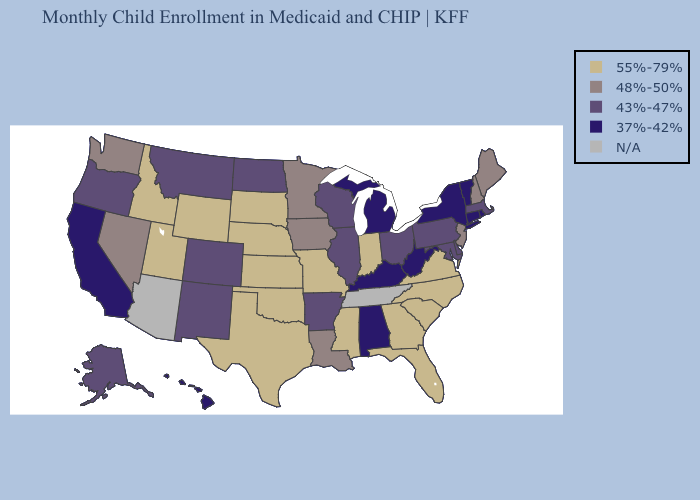Among the states that border Kentucky , does West Virginia have the lowest value?
Answer briefly. Yes. What is the lowest value in states that border Tennessee?
Answer briefly. 37%-42%. What is the value of South Dakota?
Keep it brief. 55%-79%. Among the states that border Colorado , does New Mexico have the lowest value?
Short answer required. Yes. Does the first symbol in the legend represent the smallest category?
Give a very brief answer. No. What is the value of New Mexico?
Keep it brief. 43%-47%. Name the states that have a value in the range 43%-47%?
Be succinct. Alaska, Arkansas, Colorado, Delaware, Illinois, Maryland, Massachusetts, Montana, New Mexico, North Dakota, Ohio, Oregon, Pennsylvania, Wisconsin. What is the value of Nevada?
Short answer required. 48%-50%. What is the value of Massachusetts?
Write a very short answer. 43%-47%. How many symbols are there in the legend?
Keep it brief. 5. What is the lowest value in the USA?
Write a very short answer. 37%-42%. Among the states that border Oklahoma , which have the lowest value?
Answer briefly. Arkansas, Colorado, New Mexico. Among the states that border Colorado , does New Mexico have the highest value?
Quick response, please. No. 